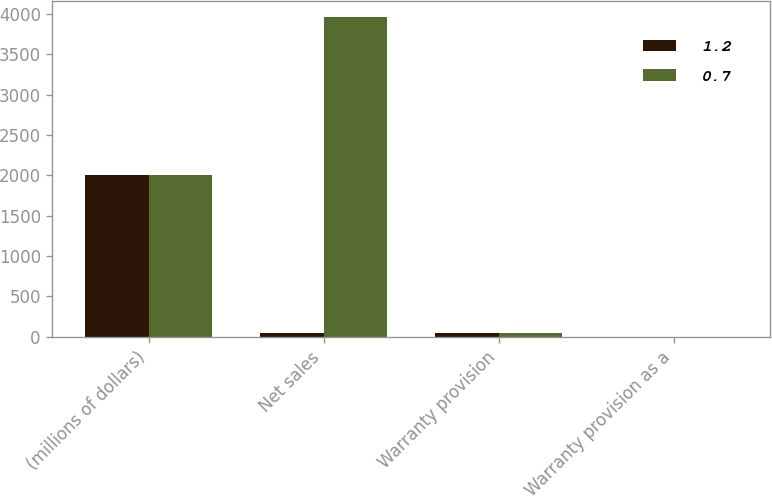Convert chart to OTSL. <chart><loc_0><loc_0><loc_500><loc_500><stacked_bar_chart><ecel><fcel>(millions of dollars)<fcel>Net sales<fcel>Warranty provision<fcel>Warranty provision as a<nl><fcel>1.2<fcel>2011<fcel>47.5<fcel>47.5<fcel>0.7<nl><fcel>0.7<fcel>2009<fcel>3961.8<fcel>46<fcel>1.2<nl></chart> 